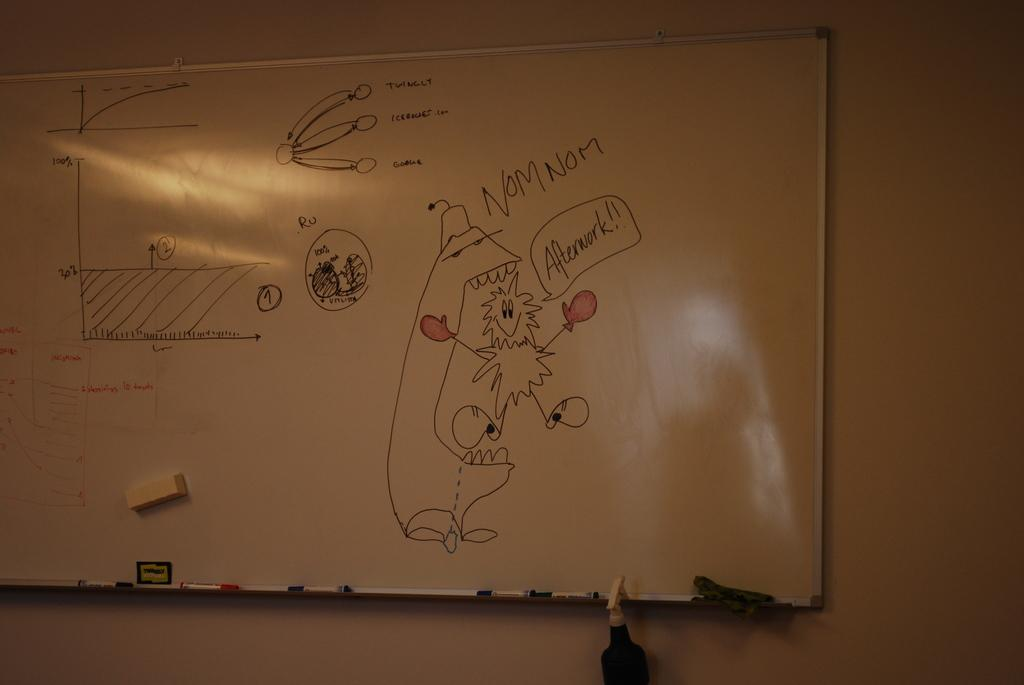<image>
Provide a brief description of the given image. A white board shows graphs along with a cartoon figure with red gloves saying "nom nom". 